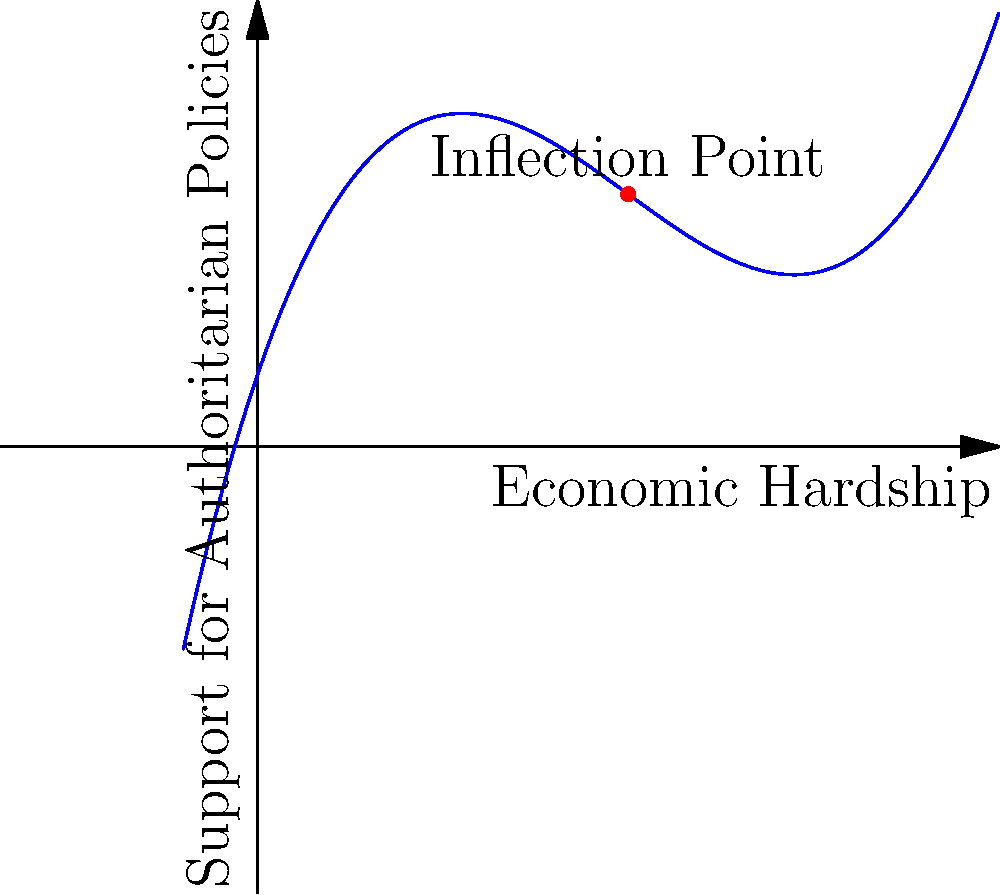The graph shows the relationship between economic hardship and support for authoritarian policies. The function describing this relationship is given by $f(x) = 0.1x^3 - 1.5x^2 + 6x + 2$, where $x$ represents economic hardship and $f(x)$ represents support for authoritarian policies. Find the inflection point of this curve. To find the inflection point, we need to follow these steps:

1) The inflection point occurs where the second derivative of the function equals zero.

2) First, let's find the first derivative:
   $f'(x) = 0.3x^2 - 3x + 6$

3) Now, let's find the second derivative:
   $f''(x) = 0.6x - 3$

4) Set the second derivative equal to zero and solve for x:
   $0.6x - 3 = 0$
   $0.6x = 3$
   $x = 5$

5) To confirm this is an inflection point, we need to verify that the second derivative changes sign at this point. We can do this by checking the values of $f''(x)$ just before and after $x=5$:
   
   At $x=4.9$: $f''(4.9) = 0.6(4.9) - 3 = -0.06$ (negative)
   At $x=5.1$: $f''(5.1) = 0.6(5.1) - 3 = 0.06$ (positive)

   The second derivative changes from negative to positive at $x=5$, confirming it's an inflection point.

6) To find the y-coordinate of the inflection point, we substitute $x=5$ into the original function:
   $f(5) = 0.1(5^3) - 1.5(5^2) + 6(5) + 2 = 12.5$

Therefore, the inflection point is at (5, 12.5).
Answer: (5, 12.5) 